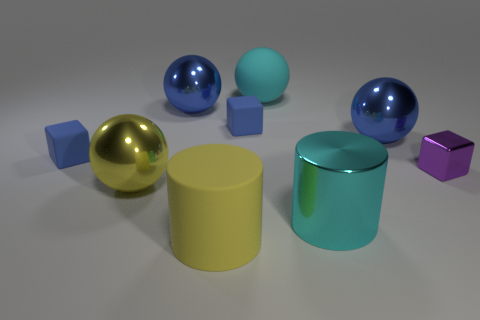Does the yellow shiny object have the same shape as the cyan object that is behind the big metal cylinder? Yes, the yellow shiny object, which appears to be a sphere, has the same spherical shape as the cyan object located behind the large metal cylinder. 